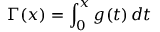Convert formula to latex. <formula><loc_0><loc_0><loc_500><loc_500>\Gamma ( x ) = \int _ { 0 } ^ { x } g ( t ) \, d t</formula> 